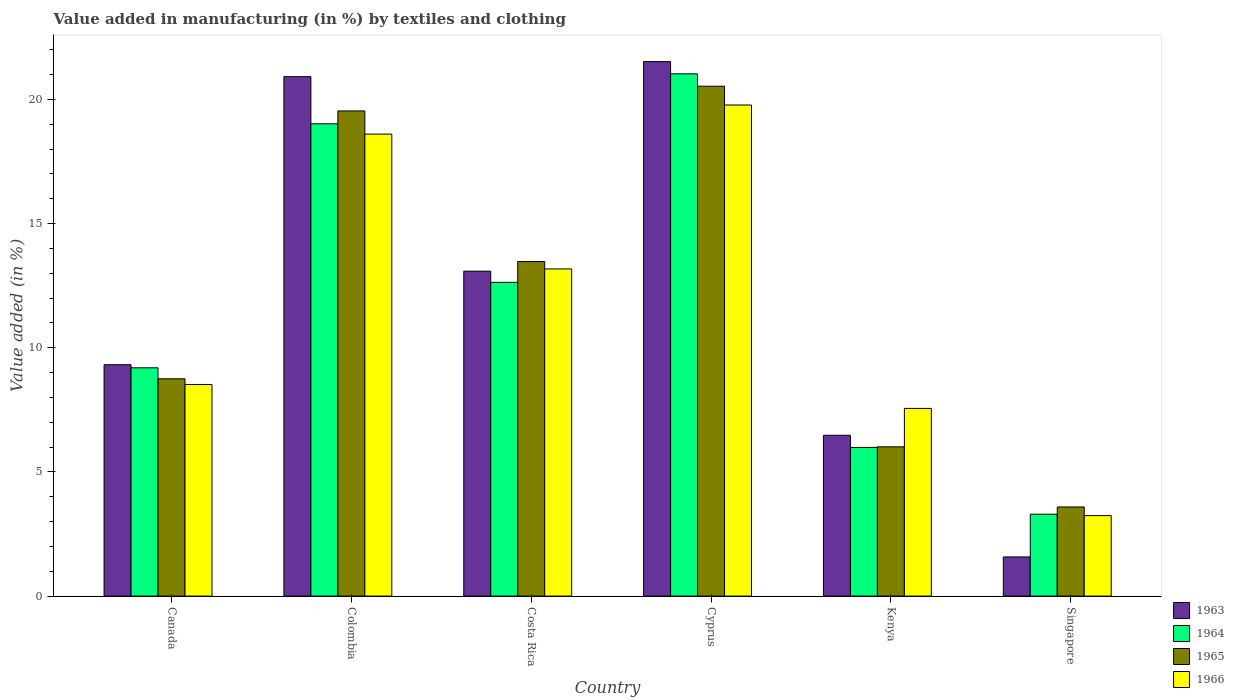How many groups of bars are there?
Your answer should be compact. 6. Are the number of bars on each tick of the X-axis equal?
Your answer should be very brief. Yes. How many bars are there on the 5th tick from the left?
Provide a succinct answer. 4. What is the label of the 3rd group of bars from the left?
Make the answer very short. Costa Rica. What is the percentage of value added in manufacturing by textiles and clothing in 1965 in Canada?
Your response must be concise. 8.75. Across all countries, what is the maximum percentage of value added in manufacturing by textiles and clothing in 1963?
Provide a succinct answer. 21.52. Across all countries, what is the minimum percentage of value added in manufacturing by textiles and clothing in 1964?
Provide a short and direct response. 3.3. In which country was the percentage of value added in manufacturing by textiles and clothing in 1963 maximum?
Your answer should be compact. Cyprus. In which country was the percentage of value added in manufacturing by textiles and clothing in 1966 minimum?
Your response must be concise. Singapore. What is the total percentage of value added in manufacturing by textiles and clothing in 1965 in the graph?
Provide a succinct answer. 71.89. What is the difference between the percentage of value added in manufacturing by textiles and clothing in 1964 in Canada and that in Singapore?
Ensure brevity in your answer.  5.9. What is the difference between the percentage of value added in manufacturing by textiles and clothing in 1966 in Singapore and the percentage of value added in manufacturing by textiles and clothing in 1965 in Kenya?
Your answer should be very brief. -2.77. What is the average percentage of value added in manufacturing by textiles and clothing in 1963 per country?
Offer a very short reply. 12.15. What is the difference between the percentage of value added in manufacturing by textiles and clothing of/in 1965 and percentage of value added in manufacturing by textiles and clothing of/in 1963 in Costa Rica?
Provide a short and direct response. 0.39. What is the ratio of the percentage of value added in manufacturing by textiles and clothing in 1963 in Costa Rica to that in Singapore?
Offer a terse response. 8.3. Is the difference between the percentage of value added in manufacturing by textiles and clothing in 1965 in Cyprus and Kenya greater than the difference between the percentage of value added in manufacturing by textiles and clothing in 1963 in Cyprus and Kenya?
Give a very brief answer. No. What is the difference between the highest and the second highest percentage of value added in manufacturing by textiles and clothing in 1964?
Provide a succinct answer. 6.38. What is the difference between the highest and the lowest percentage of value added in manufacturing by textiles and clothing in 1965?
Provide a short and direct response. 16.94. Is the sum of the percentage of value added in manufacturing by textiles and clothing in 1964 in Cyprus and Kenya greater than the maximum percentage of value added in manufacturing by textiles and clothing in 1966 across all countries?
Give a very brief answer. Yes. Is it the case that in every country, the sum of the percentage of value added in manufacturing by textiles and clothing in 1965 and percentage of value added in manufacturing by textiles and clothing in 1963 is greater than the sum of percentage of value added in manufacturing by textiles and clothing in 1966 and percentage of value added in manufacturing by textiles and clothing in 1964?
Provide a succinct answer. No. What does the 4th bar from the left in Costa Rica represents?
Ensure brevity in your answer.  1966. How many bars are there?
Your response must be concise. 24. Are all the bars in the graph horizontal?
Your response must be concise. No. What is the difference between two consecutive major ticks on the Y-axis?
Make the answer very short. 5. Does the graph contain any zero values?
Make the answer very short. No. Where does the legend appear in the graph?
Keep it short and to the point. Bottom right. How many legend labels are there?
Keep it short and to the point. 4. What is the title of the graph?
Your answer should be very brief. Value added in manufacturing (in %) by textiles and clothing. Does "1992" appear as one of the legend labels in the graph?
Your answer should be very brief. No. What is the label or title of the X-axis?
Offer a terse response. Country. What is the label or title of the Y-axis?
Your answer should be compact. Value added (in %). What is the Value added (in %) of 1963 in Canada?
Your response must be concise. 9.32. What is the Value added (in %) in 1964 in Canada?
Give a very brief answer. 9.19. What is the Value added (in %) of 1965 in Canada?
Provide a succinct answer. 8.75. What is the Value added (in %) of 1966 in Canada?
Provide a short and direct response. 8.52. What is the Value added (in %) in 1963 in Colombia?
Offer a terse response. 20.92. What is the Value added (in %) of 1964 in Colombia?
Offer a terse response. 19.02. What is the Value added (in %) in 1965 in Colombia?
Offer a very short reply. 19.54. What is the Value added (in %) of 1966 in Colombia?
Keep it short and to the point. 18.6. What is the Value added (in %) in 1963 in Costa Rica?
Ensure brevity in your answer.  13.08. What is the Value added (in %) of 1964 in Costa Rica?
Ensure brevity in your answer.  12.63. What is the Value added (in %) in 1965 in Costa Rica?
Give a very brief answer. 13.47. What is the Value added (in %) in 1966 in Costa Rica?
Make the answer very short. 13.17. What is the Value added (in %) in 1963 in Cyprus?
Offer a very short reply. 21.52. What is the Value added (in %) of 1964 in Cyprus?
Your answer should be compact. 21.03. What is the Value added (in %) in 1965 in Cyprus?
Your response must be concise. 20.53. What is the Value added (in %) of 1966 in Cyprus?
Offer a very short reply. 19.78. What is the Value added (in %) of 1963 in Kenya?
Your answer should be compact. 6.48. What is the Value added (in %) in 1964 in Kenya?
Offer a terse response. 5.99. What is the Value added (in %) of 1965 in Kenya?
Keep it short and to the point. 6.01. What is the Value added (in %) in 1966 in Kenya?
Keep it short and to the point. 7.56. What is the Value added (in %) of 1963 in Singapore?
Offer a very short reply. 1.58. What is the Value added (in %) in 1964 in Singapore?
Your answer should be very brief. 3.3. What is the Value added (in %) of 1965 in Singapore?
Provide a succinct answer. 3.59. What is the Value added (in %) in 1966 in Singapore?
Your answer should be compact. 3.24. Across all countries, what is the maximum Value added (in %) in 1963?
Keep it short and to the point. 21.52. Across all countries, what is the maximum Value added (in %) in 1964?
Make the answer very short. 21.03. Across all countries, what is the maximum Value added (in %) in 1965?
Offer a terse response. 20.53. Across all countries, what is the maximum Value added (in %) of 1966?
Your answer should be compact. 19.78. Across all countries, what is the minimum Value added (in %) in 1963?
Offer a very short reply. 1.58. Across all countries, what is the minimum Value added (in %) in 1964?
Ensure brevity in your answer.  3.3. Across all countries, what is the minimum Value added (in %) of 1965?
Give a very brief answer. 3.59. Across all countries, what is the minimum Value added (in %) of 1966?
Ensure brevity in your answer.  3.24. What is the total Value added (in %) in 1963 in the graph?
Provide a succinct answer. 72.9. What is the total Value added (in %) of 1964 in the graph?
Provide a succinct answer. 71.16. What is the total Value added (in %) in 1965 in the graph?
Your response must be concise. 71.89. What is the total Value added (in %) of 1966 in the graph?
Provide a succinct answer. 70.87. What is the difference between the Value added (in %) in 1963 in Canada and that in Colombia?
Your answer should be very brief. -11.6. What is the difference between the Value added (in %) in 1964 in Canada and that in Colombia?
Make the answer very short. -9.82. What is the difference between the Value added (in %) of 1965 in Canada and that in Colombia?
Give a very brief answer. -10.79. What is the difference between the Value added (in %) in 1966 in Canada and that in Colombia?
Provide a short and direct response. -10.08. What is the difference between the Value added (in %) of 1963 in Canada and that in Costa Rica?
Offer a terse response. -3.77. What is the difference between the Value added (in %) in 1964 in Canada and that in Costa Rica?
Make the answer very short. -3.44. What is the difference between the Value added (in %) of 1965 in Canada and that in Costa Rica?
Keep it short and to the point. -4.72. What is the difference between the Value added (in %) of 1966 in Canada and that in Costa Rica?
Give a very brief answer. -4.65. What is the difference between the Value added (in %) of 1963 in Canada and that in Cyprus?
Offer a very short reply. -12.21. What is the difference between the Value added (in %) of 1964 in Canada and that in Cyprus?
Offer a very short reply. -11.84. What is the difference between the Value added (in %) in 1965 in Canada and that in Cyprus?
Provide a succinct answer. -11.78. What is the difference between the Value added (in %) in 1966 in Canada and that in Cyprus?
Offer a very short reply. -11.25. What is the difference between the Value added (in %) in 1963 in Canada and that in Kenya?
Provide a short and direct response. 2.84. What is the difference between the Value added (in %) in 1964 in Canada and that in Kenya?
Give a very brief answer. 3.21. What is the difference between the Value added (in %) in 1965 in Canada and that in Kenya?
Provide a succinct answer. 2.74. What is the difference between the Value added (in %) in 1966 in Canada and that in Kenya?
Give a very brief answer. 0.96. What is the difference between the Value added (in %) in 1963 in Canada and that in Singapore?
Give a very brief answer. 7.74. What is the difference between the Value added (in %) in 1964 in Canada and that in Singapore?
Your response must be concise. 5.9. What is the difference between the Value added (in %) in 1965 in Canada and that in Singapore?
Ensure brevity in your answer.  5.16. What is the difference between the Value added (in %) of 1966 in Canada and that in Singapore?
Provide a short and direct response. 5.28. What is the difference between the Value added (in %) in 1963 in Colombia and that in Costa Rica?
Provide a succinct answer. 7.83. What is the difference between the Value added (in %) in 1964 in Colombia and that in Costa Rica?
Your answer should be very brief. 6.38. What is the difference between the Value added (in %) in 1965 in Colombia and that in Costa Rica?
Make the answer very short. 6.06. What is the difference between the Value added (in %) in 1966 in Colombia and that in Costa Rica?
Offer a terse response. 5.43. What is the difference between the Value added (in %) in 1963 in Colombia and that in Cyprus?
Give a very brief answer. -0.61. What is the difference between the Value added (in %) of 1964 in Colombia and that in Cyprus?
Your answer should be very brief. -2.01. What is the difference between the Value added (in %) of 1965 in Colombia and that in Cyprus?
Ensure brevity in your answer.  -0.99. What is the difference between the Value added (in %) in 1966 in Colombia and that in Cyprus?
Keep it short and to the point. -1.17. What is the difference between the Value added (in %) in 1963 in Colombia and that in Kenya?
Offer a terse response. 14.44. What is the difference between the Value added (in %) of 1964 in Colombia and that in Kenya?
Your answer should be compact. 13.03. What is the difference between the Value added (in %) in 1965 in Colombia and that in Kenya?
Provide a short and direct response. 13.53. What is the difference between the Value added (in %) in 1966 in Colombia and that in Kenya?
Keep it short and to the point. 11.05. What is the difference between the Value added (in %) in 1963 in Colombia and that in Singapore?
Provide a succinct answer. 19.34. What is the difference between the Value added (in %) in 1964 in Colombia and that in Singapore?
Make the answer very short. 15.72. What is the difference between the Value added (in %) in 1965 in Colombia and that in Singapore?
Your response must be concise. 15.95. What is the difference between the Value added (in %) of 1966 in Colombia and that in Singapore?
Offer a very short reply. 15.36. What is the difference between the Value added (in %) in 1963 in Costa Rica and that in Cyprus?
Provide a short and direct response. -8.44. What is the difference between the Value added (in %) of 1964 in Costa Rica and that in Cyprus?
Your answer should be very brief. -8.4. What is the difference between the Value added (in %) of 1965 in Costa Rica and that in Cyprus?
Make the answer very short. -7.06. What is the difference between the Value added (in %) of 1966 in Costa Rica and that in Cyprus?
Make the answer very short. -6.6. What is the difference between the Value added (in %) of 1963 in Costa Rica and that in Kenya?
Your answer should be compact. 6.61. What is the difference between the Value added (in %) in 1964 in Costa Rica and that in Kenya?
Your answer should be compact. 6.65. What is the difference between the Value added (in %) of 1965 in Costa Rica and that in Kenya?
Your response must be concise. 7.46. What is the difference between the Value added (in %) of 1966 in Costa Rica and that in Kenya?
Your answer should be compact. 5.62. What is the difference between the Value added (in %) of 1963 in Costa Rica and that in Singapore?
Give a very brief answer. 11.51. What is the difference between the Value added (in %) of 1964 in Costa Rica and that in Singapore?
Keep it short and to the point. 9.34. What is the difference between the Value added (in %) in 1965 in Costa Rica and that in Singapore?
Your answer should be compact. 9.88. What is the difference between the Value added (in %) in 1966 in Costa Rica and that in Singapore?
Make the answer very short. 9.93. What is the difference between the Value added (in %) in 1963 in Cyprus and that in Kenya?
Provide a short and direct response. 15.05. What is the difference between the Value added (in %) of 1964 in Cyprus and that in Kenya?
Offer a very short reply. 15.04. What is the difference between the Value added (in %) in 1965 in Cyprus and that in Kenya?
Keep it short and to the point. 14.52. What is the difference between the Value added (in %) in 1966 in Cyprus and that in Kenya?
Provide a succinct answer. 12.22. What is the difference between the Value added (in %) in 1963 in Cyprus and that in Singapore?
Your answer should be very brief. 19.95. What is the difference between the Value added (in %) in 1964 in Cyprus and that in Singapore?
Your response must be concise. 17.73. What is the difference between the Value added (in %) of 1965 in Cyprus and that in Singapore?
Provide a short and direct response. 16.94. What is the difference between the Value added (in %) in 1966 in Cyprus and that in Singapore?
Give a very brief answer. 16.53. What is the difference between the Value added (in %) of 1963 in Kenya and that in Singapore?
Keep it short and to the point. 4.9. What is the difference between the Value added (in %) in 1964 in Kenya and that in Singapore?
Provide a short and direct response. 2.69. What is the difference between the Value added (in %) of 1965 in Kenya and that in Singapore?
Offer a very short reply. 2.42. What is the difference between the Value added (in %) in 1966 in Kenya and that in Singapore?
Offer a very short reply. 4.32. What is the difference between the Value added (in %) of 1963 in Canada and the Value added (in %) of 1964 in Colombia?
Make the answer very short. -9.7. What is the difference between the Value added (in %) of 1963 in Canada and the Value added (in %) of 1965 in Colombia?
Your response must be concise. -10.22. What is the difference between the Value added (in %) of 1963 in Canada and the Value added (in %) of 1966 in Colombia?
Offer a very short reply. -9.29. What is the difference between the Value added (in %) of 1964 in Canada and the Value added (in %) of 1965 in Colombia?
Keep it short and to the point. -10.34. What is the difference between the Value added (in %) of 1964 in Canada and the Value added (in %) of 1966 in Colombia?
Provide a succinct answer. -9.41. What is the difference between the Value added (in %) of 1965 in Canada and the Value added (in %) of 1966 in Colombia?
Your answer should be compact. -9.85. What is the difference between the Value added (in %) of 1963 in Canada and the Value added (in %) of 1964 in Costa Rica?
Your response must be concise. -3.32. What is the difference between the Value added (in %) in 1963 in Canada and the Value added (in %) in 1965 in Costa Rica?
Keep it short and to the point. -4.16. What is the difference between the Value added (in %) in 1963 in Canada and the Value added (in %) in 1966 in Costa Rica?
Offer a terse response. -3.86. What is the difference between the Value added (in %) in 1964 in Canada and the Value added (in %) in 1965 in Costa Rica?
Provide a succinct answer. -4.28. What is the difference between the Value added (in %) in 1964 in Canada and the Value added (in %) in 1966 in Costa Rica?
Your response must be concise. -3.98. What is the difference between the Value added (in %) of 1965 in Canada and the Value added (in %) of 1966 in Costa Rica?
Your response must be concise. -4.42. What is the difference between the Value added (in %) of 1963 in Canada and the Value added (in %) of 1964 in Cyprus?
Give a very brief answer. -11.71. What is the difference between the Value added (in %) in 1963 in Canada and the Value added (in %) in 1965 in Cyprus?
Your answer should be very brief. -11.21. What is the difference between the Value added (in %) of 1963 in Canada and the Value added (in %) of 1966 in Cyprus?
Provide a short and direct response. -10.46. What is the difference between the Value added (in %) of 1964 in Canada and the Value added (in %) of 1965 in Cyprus?
Provide a succinct answer. -11.34. What is the difference between the Value added (in %) of 1964 in Canada and the Value added (in %) of 1966 in Cyprus?
Ensure brevity in your answer.  -10.58. What is the difference between the Value added (in %) of 1965 in Canada and the Value added (in %) of 1966 in Cyprus?
Provide a short and direct response. -11.02. What is the difference between the Value added (in %) in 1963 in Canada and the Value added (in %) in 1964 in Kenya?
Your answer should be compact. 3.33. What is the difference between the Value added (in %) of 1963 in Canada and the Value added (in %) of 1965 in Kenya?
Ensure brevity in your answer.  3.31. What is the difference between the Value added (in %) in 1963 in Canada and the Value added (in %) in 1966 in Kenya?
Provide a short and direct response. 1.76. What is the difference between the Value added (in %) of 1964 in Canada and the Value added (in %) of 1965 in Kenya?
Keep it short and to the point. 3.18. What is the difference between the Value added (in %) of 1964 in Canada and the Value added (in %) of 1966 in Kenya?
Your answer should be compact. 1.64. What is the difference between the Value added (in %) of 1965 in Canada and the Value added (in %) of 1966 in Kenya?
Give a very brief answer. 1.19. What is the difference between the Value added (in %) in 1963 in Canada and the Value added (in %) in 1964 in Singapore?
Offer a very short reply. 6.02. What is the difference between the Value added (in %) of 1963 in Canada and the Value added (in %) of 1965 in Singapore?
Give a very brief answer. 5.73. What is the difference between the Value added (in %) of 1963 in Canada and the Value added (in %) of 1966 in Singapore?
Give a very brief answer. 6.08. What is the difference between the Value added (in %) of 1964 in Canada and the Value added (in %) of 1965 in Singapore?
Make the answer very short. 5.6. What is the difference between the Value added (in %) in 1964 in Canada and the Value added (in %) in 1966 in Singapore?
Give a very brief answer. 5.95. What is the difference between the Value added (in %) in 1965 in Canada and the Value added (in %) in 1966 in Singapore?
Keep it short and to the point. 5.51. What is the difference between the Value added (in %) in 1963 in Colombia and the Value added (in %) in 1964 in Costa Rica?
Offer a terse response. 8.28. What is the difference between the Value added (in %) of 1963 in Colombia and the Value added (in %) of 1965 in Costa Rica?
Give a very brief answer. 7.44. What is the difference between the Value added (in %) of 1963 in Colombia and the Value added (in %) of 1966 in Costa Rica?
Ensure brevity in your answer.  7.74. What is the difference between the Value added (in %) of 1964 in Colombia and the Value added (in %) of 1965 in Costa Rica?
Your answer should be compact. 5.55. What is the difference between the Value added (in %) of 1964 in Colombia and the Value added (in %) of 1966 in Costa Rica?
Ensure brevity in your answer.  5.84. What is the difference between the Value added (in %) of 1965 in Colombia and the Value added (in %) of 1966 in Costa Rica?
Your answer should be compact. 6.36. What is the difference between the Value added (in %) of 1963 in Colombia and the Value added (in %) of 1964 in Cyprus?
Your answer should be compact. -0.11. What is the difference between the Value added (in %) in 1963 in Colombia and the Value added (in %) in 1965 in Cyprus?
Your response must be concise. 0.39. What is the difference between the Value added (in %) in 1963 in Colombia and the Value added (in %) in 1966 in Cyprus?
Offer a terse response. 1.14. What is the difference between the Value added (in %) in 1964 in Colombia and the Value added (in %) in 1965 in Cyprus?
Provide a succinct answer. -1.51. What is the difference between the Value added (in %) of 1964 in Colombia and the Value added (in %) of 1966 in Cyprus?
Provide a succinct answer. -0.76. What is the difference between the Value added (in %) in 1965 in Colombia and the Value added (in %) in 1966 in Cyprus?
Provide a short and direct response. -0.24. What is the difference between the Value added (in %) of 1963 in Colombia and the Value added (in %) of 1964 in Kenya?
Offer a terse response. 14.93. What is the difference between the Value added (in %) in 1963 in Colombia and the Value added (in %) in 1965 in Kenya?
Your answer should be compact. 14.91. What is the difference between the Value added (in %) in 1963 in Colombia and the Value added (in %) in 1966 in Kenya?
Ensure brevity in your answer.  13.36. What is the difference between the Value added (in %) of 1964 in Colombia and the Value added (in %) of 1965 in Kenya?
Provide a short and direct response. 13.01. What is the difference between the Value added (in %) of 1964 in Colombia and the Value added (in %) of 1966 in Kenya?
Offer a very short reply. 11.46. What is the difference between the Value added (in %) of 1965 in Colombia and the Value added (in %) of 1966 in Kenya?
Ensure brevity in your answer.  11.98. What is the difference between the Value added (in %) of 1963 in Colombia and the Value added (in %) of 1964 in Singapore?
Your response must be concise. 17.62. What is the difference between the Value added (in %) in 1963 in Colombia and the Value added (in %) in 1965 in Singapore?
Provide a succinct answer. 17.33. What is the difference between the Value added (in %) in 1963 in Colombia and the Value added (in %) in 1966 in Singapore?
Provide a short and direct response. 17.68. What is the difference between the Value added (in %) of 1964 in Colombia and the Value added (in %) of 1965 in Singapore?
Offer a terse response. 15.43. What is the difference between the Value added (in %) in 1964 in Colombia and the Value added (in %) in 1966 in Singapore?
Keep it short and to the point. 15.78. What is the difference between the Value added (in %) of 1965 in Colombia and the Value added (in %) of 1966 in Singapore?
Make the answer very short. 16.3. What is the difference between the Value added (in %) of 1963 in Costa Rica and the Value added (in %) of 1964 in Cyprus?
Provide a short and direct response. -7.95. What is the difference between the Value added (in %) in 1963 in Costa Rica and the Value added (in %) in 1965 in Cyprus?
Your response must be concise. -7.45. What is the difference between the Value added (in %) in 1963 in Costa Rica and the Value added (in %) in 1966 in Cyprus?
Your answer should be compact. -6.69. What is the difference between the Value added (in %) in 1964 in Costa Rica and the Value added (in %) in 1965 in Cyprus?
Provide a short and direct response. -7.9. What is the difference between the Value added (in %) of 1964 in Costa Rica and the Value added (in %) of 1966 in Cyprus?
Your answer should be compact. -7.14. What is the difference between the Value added (in %) of 1965 in Costa Rica and the Value added (in %) of 1966 in Cyprus?
Provide a succinct answer. -6.3. What is the difference between the Value added (in %) of 1963 in Costa Rica and the Value added (in %) of 1964 in Kenya?
Your response must be concise. 7.1. What is the difference between the Value added (in %) of 1963 in Costa Rica and the Value added (in %) of 1965 in Kenya?
Your answer should be compact. 7.07. What is the difference between the Value added (in %) of 1963 in Costa Rica and the Value added (in %) of 1966 in Kenya?
Ensure brevity in your answer.  5.53. What is the difference between the Value added (in %) of 1964 in Costa Rica and the Value added (in %) of 1965 in Kenya?
Your answer should be compact. 6.62. What is the difference between the Value added (in %) of 1964 in Costa Rica and the Value added (in %) of 1966 in Kenya?
Offer a terse response. 5.08. What is the difference between the Value added (in %) of 1965 in Costa Rica and the Value added (in %) of 1966 in Kenya?
Offer a terse response. 5.91. What is the difference between the Value added (in %) of 1963 in Costa Rica and the Value added (in %) of 1964 in Singapore?
Make the answer very short. 9.79. What is the difference between the Value added (in %) of 1963 in Costa Rica and the Value added (in %) of 1965 in Singapore?
Make the answer very short. 9.5. What is the difference between the Value added (in %) of 1963 in Costa Rica and the Value added (in %) of 1966 in Singapore?
Ensure brevity in your answer.  9.84. What is the difference between the Value added (in %) in 1964 in Costa Rica and the Value added (in %) in 1965 in Singapore?
Offer a terse response. 9.04. What is the difference between the Value added (in %) in 1964 in Costa Rica and the Value added (in %) in 1966 in Singapore?
Offer a terse response. 9.39. What is the difference between the Value added (in %) of 1965 in Costa Rica and the Value added (in %) of 1966 in Singapore?
Your answer should be compact. 10.23. What is the difference between the Value added (in %) in 1963 in Cyprus and the Value added (in %) in 1964 in Kenya?
Offer a terse response. 15.54. What is the difference between the Value added (in %) of 1963 in Cyprus and the Value added (in %) of 1965 in Kenya?
Provide a short and direct response. 15.51. What is the difference between the Value added (in %) of 1963 in Cyprus and the Value added (in %) of 1966 in Kenya?
Offer a very short reply. 13.97. What is the difference between the Value added (in %) in 1964 in Cyprus and the Value added (in %) in 1965 in Kenya?
Give a very brief answer. 15.02. What is the difference between the Value added (in %) in 1964 in Cyprus and the Value added (in %) in 1966 in Kenya?
Keep it short and to the point. 13.47. What is the difference between the Value added (in %) of 1965 in Cyprus and the Value added (in %) of 1966 in Kenya?
Make the answer very short. 12.97. What is the difference between the Value added (in %) of 1963 in Cyprus and the Value added (in %) of 1964 in Singapore?
Provide a short and direct response. 18.23. What is the difference between the Value added (in %) of 1963 in Cyprus and the Value added (in %) of 1965 in Singapore?
Your answer should be compact. 17.93. What is the difference between the Value added (in %) of 1963 in Cyprus and the Value added (in %) of 1966 in Singapore?
Make the answer very short. 18.28. What is the difference between the Value added (in %) in 1964 in Cyprus and the Value added (in %) in 1965 in Singapore?
Keep it short and to the point. 17.44. What is the difference between the Value added (in %) of 1964 in Cyprus and the Value added (in %) of 1966 in Singapore?
Keep it short and to the point. 17.79. What is the difference between the Value added (in %) in 1965 in Cyprus and the Value added (in %) in 1966 in Singapore?
Offer a terse response. 17.29. What is the difference between the Value added (in %) in 1963 in Kenya and the Value added (in %) in 1964 in Singapore?
Offer a very short reply. 3.18. What is the difference between the Value added (in %) of 1963 in Kenya and the Value added (in %) of 1965 in Singapore?
Ensure brevity in your answer.  2.89. What is the difference between the Value added (in %) of 1963 in Kenya and the Value added (in %) of 1966 in Singapore?
Your answer should be compact. 3.24. What is the difference between the Value added (in %) in 1964 in Kenya and the Value added (in %) in 1965 in Singapore?
Offer a very short reply. 2.4. What is the difference between the Value added (in %) in 1964 in Kenya and the Value added (in %) in 1966 in Singapore?
Provide a short and direct response. 2.75. What is the difference between the Value added (in %) of 1965 in Kenya and the Value added (in %) of 1966 in Singapore?
Provide a short and direct response. 2.77. What is the average Value added (in %) of 1963 per country?
Ensure brevity in your answer.  12.15. What is the average Value added (in %) of 1964 per country?
Provide a short and direct response. 11.86. What is the average Value added (in %) in 1965 per country?
Your answer should be compact. 11.98. What is the average Value added (in %) in 1966 per country?
Make the answer very short. 11.81. What is the difference between the Value added (in %) in 1963 and Value added (in %) in 1964 in Canada?
Give a very brief answer. 0.12. What is the difference between the Value added (in %) in 1963 and Value added (in %) in 1965 in Canada?
Keep it short and to the point. 0.57. What is the difference between the Value added (in %) of 1963 and Value added (in %) of 1966 in Canada?
Make the answer very short. 0.8. What is the difference between the Value added (in %) of 1964 and Value added (in %) of 1965 in Canada?
Your answer should be very brief. 0.44. What is the difference between the Value added (in %) of 1964 and Value added (in %) of 1966 in Canada?
Your response must be concise. 0.67. What is the difference between the Value added (in %) in 1965 and Value added (in %) in 1966 in Canada?
Offer a very short reply. 0.23. What is the difference between the Value added (in %) in 1963 and Value added (in %) in 1964 in Colombia?
Offer a terse response. 1.9. What is the difference between the Value added (in %) in 1963 and Value added (in %) in 1965 in Colombia?
Offer a terse response. 1.38. What is the difference between the Value added (in %) in 1963 and Value added (in %) in 1966 in Colombia?
Give a very brief answer. 2.31. What is the difference between the Value added (in %) of 1964 and Value added (in %) of 1965 in Colombia?
Your answer should be very brief. -0.52. What is the difference between the Value added (in %) of 1964 and Value added (in %) of 1966 in Colombia?
Your response must be concise. 0.41. What is the difference between the Value added (in %) in 1965 and Value added (in %) in 1966 in Colombia?
Give a very brief answer. 0.93. What is the difference between the Value added (in %) in 1963 and Value added (in %) in 1964 in Costa Rica?
Provide a succinct answer. 0.45. What is the difference between the Value added (in %) of 1963 and Value added (in %) of 1965 in Costa Rica?
Keep it short and to the point. -0.39. What is the difference between the Value added (in %) of 1963 and Value added (in %) of 1966 in Costa Rica?
Offer a very short reply. -0.09. What is the difference between the Value added (in %) of 1964 and Value added (in %) of 1965 in Costa Rica?
Your answer should be compact. -0.84. What is the difference between the Value added (in %) in 1964 and Value added (in %) in 1966 in Costa Rica?
Your response must be concise. -0.54. What is the difference between the Value added (in %) in 1965 and Value added (in %) in 1966 in Costa Rica?
Your response must be concise. 0.3. What is the difference between the Value added (in %) of 1963 and Value added (in %) of 1964 in Cyprus?
Make the answer very short. 0.49. What is the difference between the Value added (in %) in 1963 and Value added (in %) in 1966 in Cyprus?
Provide a short and direct response. 1.75. What is the difference between the Value added (in %) of 1964 and Value added (in %) of 1965 in Cyprus?
Your answer should be very brief. 0.5. What is the difference between the Value added (in %) in 1964 and Value added (in %) in 1966 in Cyprus?
Your answer should be compact. 1.25. What is the difference between the Value added (in %) in 1965 and Value added (in %) in 1966 in Cyprus?
Provide a succinct answer. 0.76. What is the difference between the Value added (in %) in 1963 and Value added (in %) in 1964 in Kenya?
Keep it short and to the point. 0.49. What is the difference between the Value added (in %) in 1963 and Value added (in %) in 1965 in Kenya?
Offer a very short reply. 0.47. What is the difference between the Value added (in %) of 1963 and Value added (in %) of 1966 in Kenya?
Offer a terse response. -1.08. What is the difference between the Value added (in %) in 1964 and Value added (in %) in 1965 in Kenya?
Keep it short and to the point. -0.02. What is the difference between the Value added (in %) of 1964 and Value added (in %) of 1966 in Kenya?
Keep it short and to the point. -1.57. What is the difference between the Value added (in %) in 1965 and Value added (in %) in 1966 in Kenya?
Give a very brief answer. -1.55. What is the difference between the Value added (in %) of 1963 and Value added (in %) of 1964 in Singapore?
Offer a terse response. -1.72. What is the difference between the Value added (in %) in 1963 and Value added (in %) in 1965 in Singapore?
Ensure brevity in your answer.  -2.01. What is the difference between the Value added (in %) in 1963 and Value added (in %) in 1966 in Singapore?
Provide a succinct answer. -1.66. What is the difference between the Value added (in %) in 1964 and Value added (in %) in 1965 in Singapore?
Your answer should be compact. -0.29. What is the difference between the Value added (in %) of 1964 and Value added (in %) of 1966 in Singapore?
Provide a short and direct response. 0.06. What is the difference between the Value added (in %) of 1965 and Value added (in %) of 1966 in Singapore?
Your answer should be compact. 0.35. What is the ratio of the Value added (in %) of 1963 in Canada to that in Colombia?
Your answer should be very brief. 0.45. What is the ratio of the Value added (in %) of 1964 in Canada to that in Colombia?
Offer a terse response. 0.48. What is the ratio of the Value added (in %) in 1965 in Canada to that in Colombia?
Offer a very short reply. 0.45. What is the ratio of the Value added (in %) in 1966 in Canada to that in Colombia?
Your answer should be very brief. 0.46. What is the ratio of the Value added (in %) in 1963 in Canada to that in Costa Rica?
Your answer should be very brief. 0.71. What is the ratio of the Value added (in %) in 1964 in Canada to that in Costa Rica?
Your response must be concise. 0.73. What is the ratio of the Value added (in %) of 1965 in Canada to that in Costa Rica?
Your response must be concise. 0.65. What is the ratio of the Value added (in %) in 1966 in Canada to that in Costa Rica?
Give a very brief answer. 0.65. What is the ratio of the Value added (in %) in 1963 in Canada to that in Cyprus?
Make the answer very short. 0.43. What is the ratio of the Value added (in %) of 1964 in Canada to that in Cyprus?
Keep it short and to the point. 0.44. What is the ratio of the Value added (in %) in 1965 in Canada to that in Cyprus?
Your response must be concise. 0.43. What is the ratio of the Value added (in %) of 1966 in Canada to that in Cyprus?
Your answer should be very brief. 0.43. What is the ratio of the Value added (in %) of 1963 in Canada to that in Kenya?
Offer a terse response. 1.44. What is the ratio of the Value added (in %) of 1964 in Canada to that in Kenya?
Your response must be concise. 1.54. What is the ratio of the Value added (in %) of 1965 in Canada to that in Kenya?
Your response must be concise. 1.46. What is the ratio of the Value added (in %) of 1966 in Canada to that in Kenya?
Your response must be concise. 1.13. What is the ratio of the Value added (in %) in 1963 in Canada to that in Singapore?
Your response must be concise. 5.91. What is the ratio of the Value added (in %) in 1964 in Canada to that in Singapore?
Provide a succinct answer. 2.79. What is the ratio of the Value added (in %) in 1965 in Canada to that in Singapore?
Offer a very short reply. 2.44. What is the ratio of the Value added (in %) of 1966 in Canada to that in Singapore?
Offer a very short reply. 2.63. What is the ratio of the Value added (in %) in 1963 in Colombia to that in Costa Rica?
Make the answer very short. 1.6. What is the ratio of the Value added (in %) of 1964 in Colombia to that in Costa Rica?
Give a very brief answer. 1.51. What is the ratio of the Value added (in %) of 1965 in Colombia to that in Costa Rica?
Your answer should be compact. 1.45. What is the ratio of the Value added (in %) of 1966 in Colombia to that in Costa Rica?
Ensure brevity in your answer.  1.41. What is the ratio of the Value added (in %) in 1963 in Colombia to that in Cyprus?
Provide a short and direct response. 0.97. What is the ratio of the Value added (in %) of 1964 in Colombia to that in Cyprus?
Provide a short and direct response. 0.9. What is the ratio of the Value added (in %) in 1965 in Colombia to that in Cyprus?
Offer a very short reply. 0.95. What is the ratio of the Value added (in %) in 1966 in Colombia to that in Cyprus?
Your answer should be very brief. 0.94. What is the ratio of the Value added (in %) of 1963 in Colombia to that in Kenya?
Make the answer very short. 3.23. What is the ratio of the Value added (in %) of 1964 in Colombia to that in Kenya?
Offer a terse response. 3.18. What is the ratio of the Value added (in %) in 1966 in Colombia to that in Kenya?
Make the answer very short. 2.46. What is the ratio of the Value added (in %) of 1963 in Colombia to that in Singapore?
Your answer should be very brief. 13.26. What is the ratio of the Value added (in %) in 1964 in Colombia to that in Singapore?
Your answer should be very brief. 5.77. What is the ratio of the Value added (in %) in 1965 in Colombia to that in Singapore?
Ensure brevity in your answer.  5.44. What is the ratio of the Value added (in %) of 1966 in Colombia to that in Singapore?
Offer a very short reply. 5.74. What is the ratio of the Value added (in %) in 1963 in Costa Rica to that in Cyprus?
Keep it short and to the point. 0.61. What is the ratio of the Value added (in %) of 1964 in Costa Rica to that in Cyprus?
Your answer should be compact. 0.6. What is the ratio of the Value added (in %) in 1965 in Costa Rica to that in Cyprus?
Offer a very short reply. 0.66. What is the ratio of the Value added (in %) of 1966 in Costa Rica to that in Cyprus?
Keep it short and to the point. 0.67. What is the ratio of the Value added (in %) in 1963 in Costa Rica to that in Kenya?
Ensure brevity in your answer.  2.02. What is the ratio of the Value added (in %) of 1964 in Costa Rica to that in Kenya?
Your answer should be very brief. 2.11. What is the ratio of the Value added (in %) in 1965 in Costa Rica to that in Kenya?
Ensure brevity in your answer.  2.24. What is the ratio of the Value added (in %) of 1966 in Costa Rica to that in Kenya?
Your answer should be compact. 1.74. What is the ratio of the Value added (in %) in 1963 in Costa Rica to that in Singapore?
Ensure brevity in your answer.  8.3. What is the ratio of the Value added (in %) of 1964 in Costa Rica to that in Singapore?
Ensure brevity in your answer.  3.83. What is the ratio of the Value added (in %) of 1965 in Costa Rica to that in Singapore?
Make the answer very short. 3.75. What is the ratio of the Value added (in %) of 1966 in Costa Rica to that in Singapore?
Provide a short and direct response. 4.06. What is the ratio of the Value added (in %) in 1963 in Cyprus to that in Kenya?
Provide a succinct answer. 3.32. What is the ratio of the Value added (in %) in 1964 in Cyprus to that in Kenya?
Keep it short and to the point. 3.51. What is the ratio of the Value added (in %) of 1965 in Cyprus to that in Kenya?
Offer a terse response. 3.42. What is the ratio of the Value added (in %) of 1966 in Cyprus to that in Kenya?
Provide a short and direct response. 2.62. What is the ratio of the Value added (in %) of 1963 in Cyprus to that in Singapore?
Keep it short and to the point. 13.65. What is the ratio of the Value added (in %) in 1964 in Cyprus to that in Singapore?
Provide a succinct answer. 6.38. What is the ratio of the Value added (in %) in 1965 in Cyprus to that in Singapore?
Your response must be concise. 5.72. What is the ratio of the Value added (in %) in 1966 in Cyprus to that in Singapore?
Keep it short and to the point. 6.1. What is the ratio of the Value added (in %) of 1963 in Kenya to that in Singapore?
Your response must be concise. 4.11. What is the ratio of the Value added (in %) in 1964 in Kenya to that in Singapore?
Make the answer very short. 1.82. What is the ratio of the Value added (in %) of 1965 in Kenya to that in Singapore?
Your response must be concise. 1.67. What is the ratio of the Value added (in %) in 1966 in Kenya to that in Singapore?
Provide a short and direct response. 2.33. What is the difference between the highest and the second highest Value added (in %) of 1963?
Offer a very short reply. 0.61. What is the difference between the highest and the second highest Value added (in %) in 1964?
Your answer should be very brief. 2.01. What is the difference between the highest and the second highest Value added (in %) of 1965?
Your answer should be very brief. 0.99. What is the difference between the highest and the second highest Value added (in %) of 1966?
Your answer should be very brief. 1.17. What is the difference between the highest and the lowest Value added (in %) in 1963?
Your response must be concise. 19.95. What is the difference between the highest and the lowest Value added (in %) of 1964?
Make the answer very short. 17.73. What is the difference between the highest and the lowest Value added (in %) of 1965?
Provide a succinct answer. 16.94. What is the difference between the highest and the lowest Value added (in %) of 1966?
Provide a succinct answer. 16.53. 